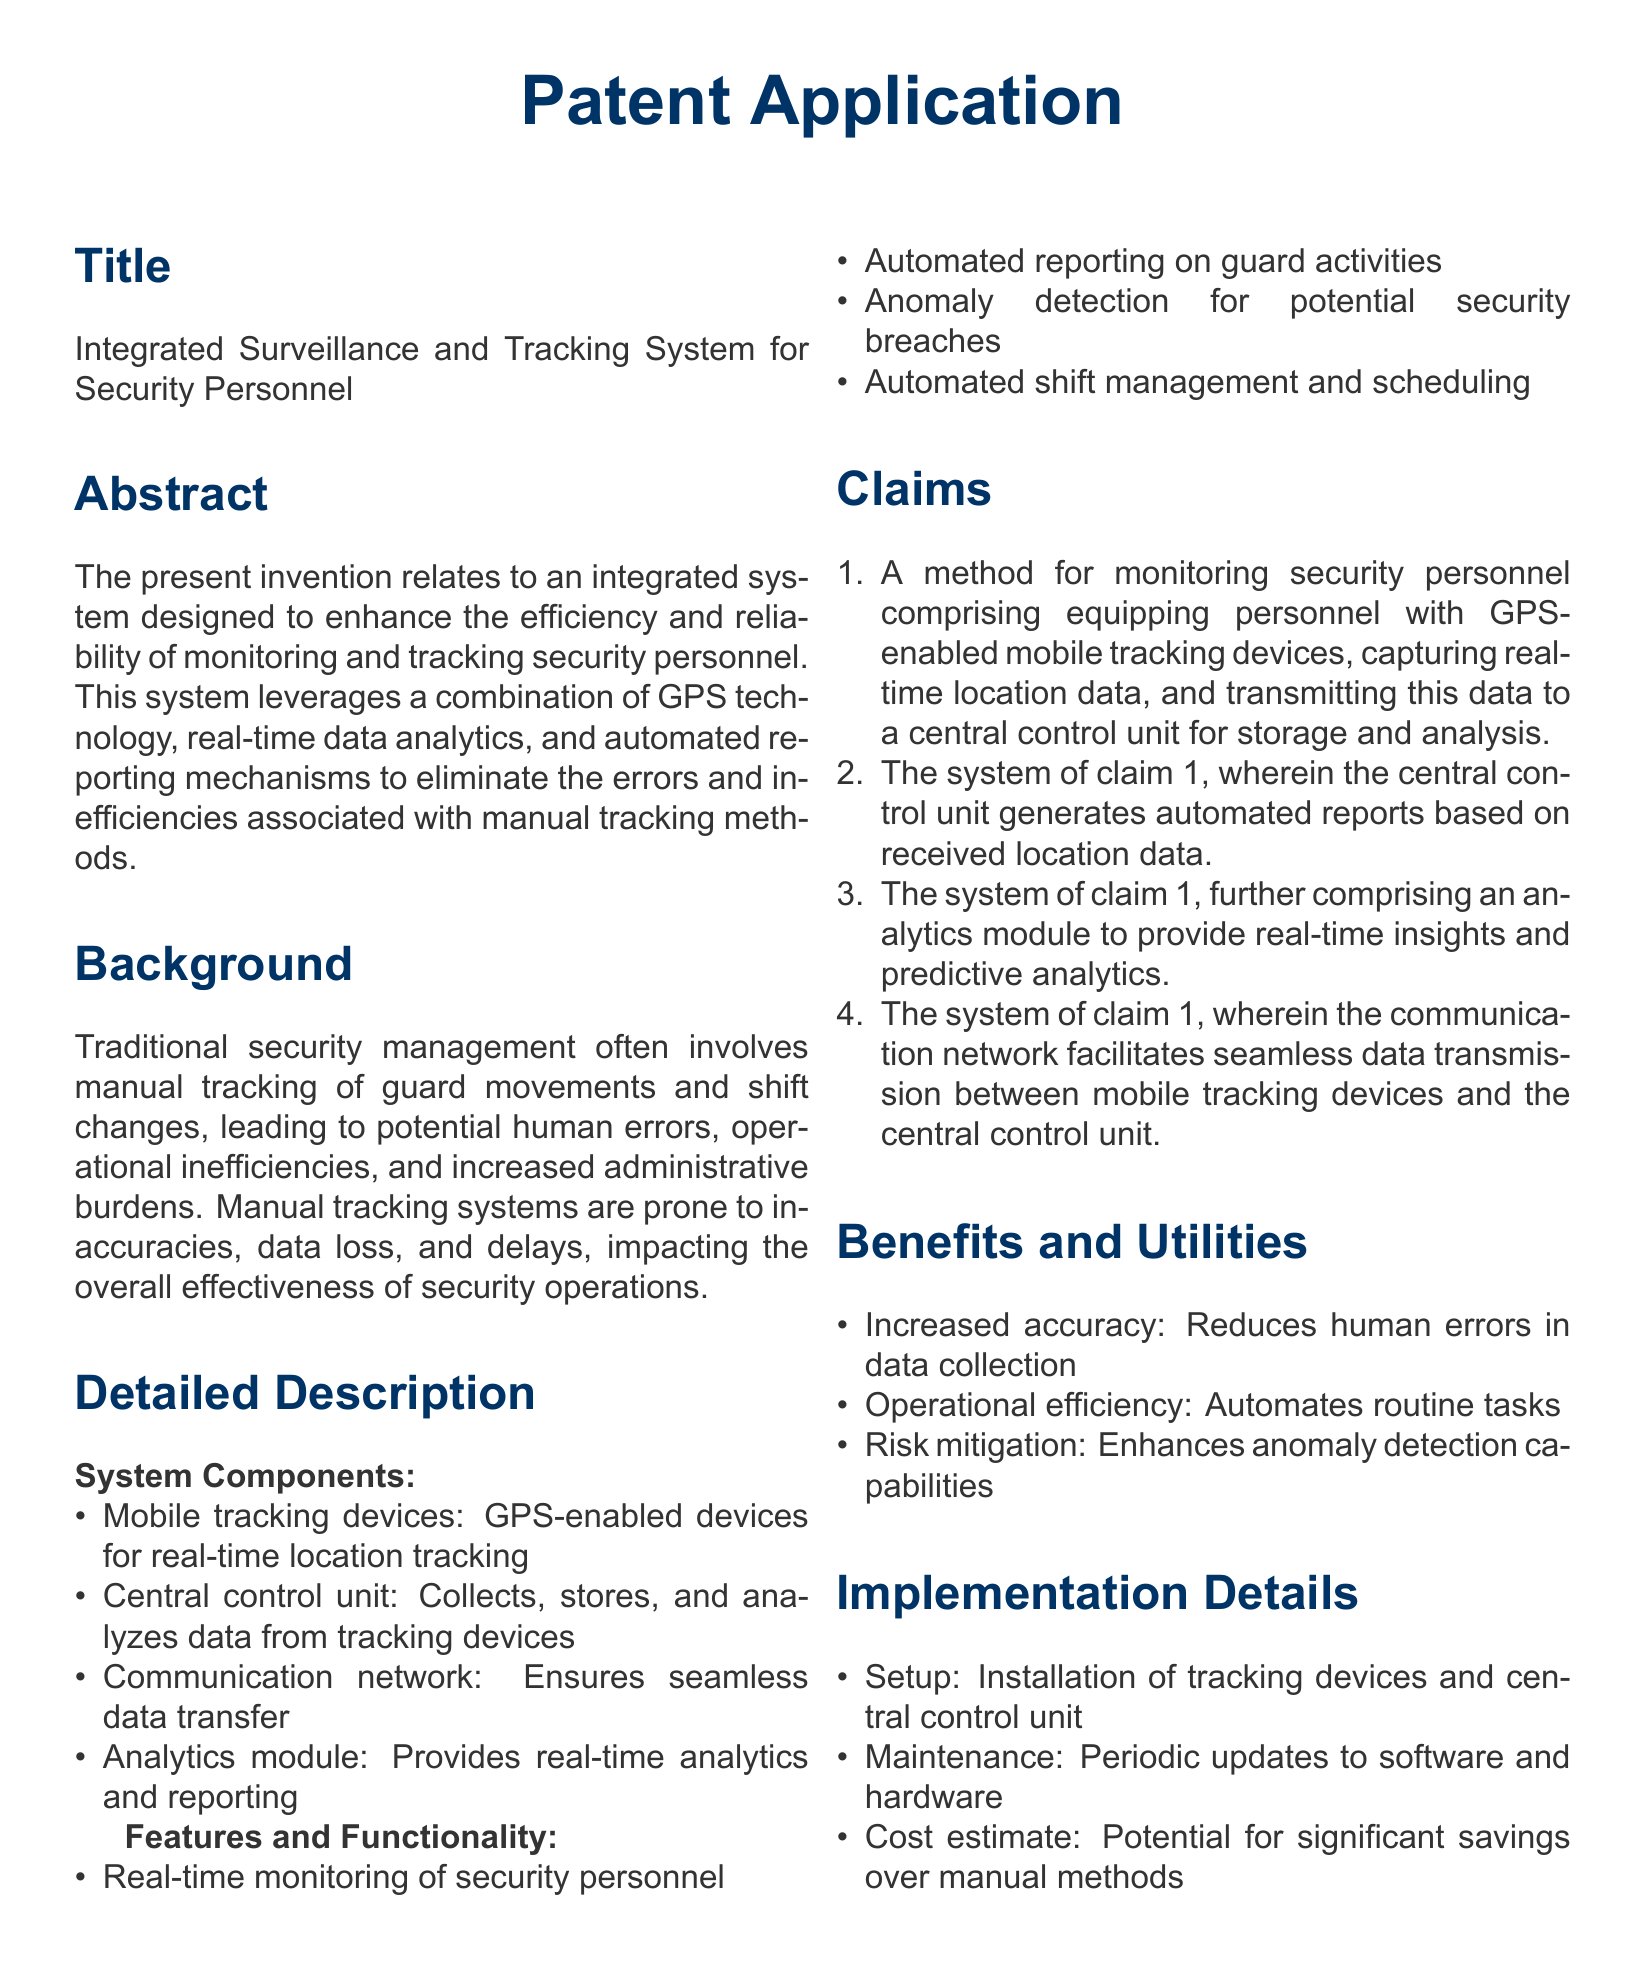What is the title of the patent application? The title is presented in the document, specifically under the Title section.
Answer: Integrated Surveillance and Tracking System for Security Personnel What technology does the system leverage for tracking? The document mentions the specific technology leveraged for tracking in the Abstract.
Answer: GPS technology What are the main components of the system? The components are listed in the Detailed Description section.
Answer: Mobile tracking devices, Central control unit, Communication network, Analytics module How does the system improve operational efficiency? The document explains the operational efficiency improvements in the Benefits and Utilities section.
Answer: Automates routine tasks What is one feature of the system? The features are outlined in the Features and Functionality section.
Answer: Real-time monitoring of security personnel What is the primary claim of the patent application? The claims section lists the primary method for monitoring security personnel.
Answer: A method for monitoring security personnel comprising equipping personnel with GPS-enabled mobile tracking devices What type of reporting does the system provide? The document states the type of reporting provided in the Features and Functionality section.
Answer: Automated reporting on guard activities What is a benefit of using this system over manual methods? The Benefits and Utilities section lists advantages of the new system.
Answer: Increased accuracy How is data transmitted in the system? The method of data transmission is detailed in the claims section of the document.
Answer: Communication network facilitates seamless data transmission What are the implementation details mentioned? The Implementation Details section outlines the setup process.
Answer: Installation of tracking devices and central control unit 